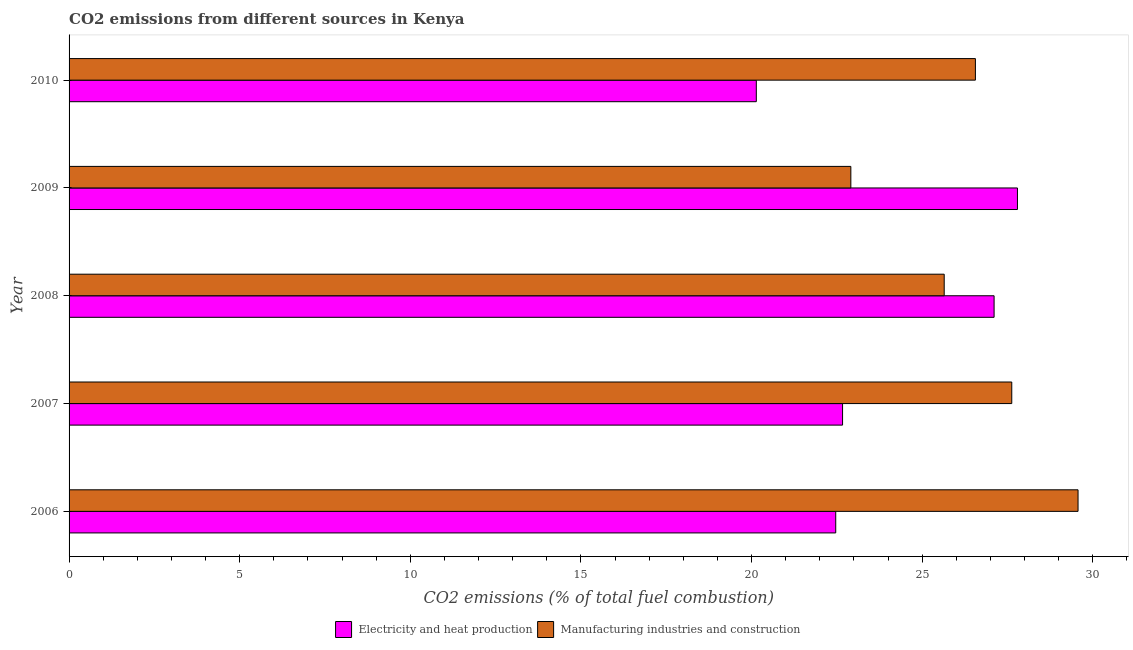How many different coloured bars are there?
Give a very brief answer. 2. Are the number of bars on each tick of the Y-axis equal?
Keep it short and to the point. Yes. How many bars are there on the 5th tick from the bottom?
Ensure brevity in your answer.  2. What is the co2 emissions due to manufacturing industries in 2008?
Give a very brief answer. 25.65. Across all years, what is the maximum co2 emissions due to manufacturing industries?
Your answer should be very brief. 29.57. Across all years, what is the minimum co2 emissions due to electricity and heat production?
Give a very brief answer. 20.14. What is the total co2 emissions due to manufacturing industries in the graph?
Your response must be concise. 132.31. What is the difference between the co2 emissions due to electricity and heat production in 2009 and the co2 emissions due to manufacturing industries in 2008?
Ensure brevity in your answer.  2.15. What is the average co2 emissions due to electricity and heat production per year?
Provide a short and direct response. 24.04. In the year 2007, what is the difference between the co2 emissions due to electricity and heat production and co2 emissions due to manufacturing industries?
Give a very brief answer. -4.96. What is the ratio of the co2 emissions due to manufacturing industries in 2009 to that in 2010?
Offer a very short reply. 0.86. Is the difference between the co2 emissions due to manufacturing industries in 2007 and 2008 greater than the difference between the co2 emissions due to electricity and heat production in 2007 and 2008?
Offer a very short reply. Yes. What is the difference between the highest and the second highest co2 emissions due to electricity and heat production?
Keep it short and to the point. 0.68. What is the difference between the highest and the lowest co2 emissions due to manufacturing industries?
Provide a succinct answer. 6.66. In how many years, is the co2 emissions due to electricity and heat production greater than the average co2 emissions due to electricity and heat production taken over all years?
Give a very brief answer. 2. Is the sum of the co2 emissions due to electricity and heat production in 2006 and 2007 greater than the maximum co2 emissions due to manufacturing industries across all years?
Your response must be concise. Yes. What does the 1st bar from the top in 2006 represents?
Offer a terse response. Manufacturing industries and construction. What does the 1st bar from the bottom in 2009 represents?
Give a very brief answer. Electricity and heat production. Are the values on the major ticks of X-axis written in scientific E-notation?
Your response must be concise. No. Does the graph contain any zero values?
Give a very brief answer. No. How many legend labels are there?
Give a very brief answer. 2. What is the title of the graph?
Keep it short and to the point. CO2 emissions from different sources in Kenya. Does "Subsidies" appear as one of the legend labels in the graph?
Your answer should be very brief. No. What is the label or title of the X-axis?
Your response must be concise. CO2 emissions (% of total fuel combustion). What is the label or title of the Y-axis?
Your response must be concise. Year. What is the CO2 emissions (% of total fuel combustion) of Electricity and heat production in 2006?
Provide a short and direct response. 22.47. What is the CO2 emissions (% of total fuel combustion) of Manufacturing industries and construction in 2006?
Your answer should be very brief. 29.57. What is the CO2 emissions (% of total fuel combustion) of Electricity and heat production in 2007?
Provide a succinct answer. 22.67. What is the CO2 emissions (% of total fuel combustion) of Manufacturing industries and construction in 2007?
Provide a short and direct response. 27.63. What is the CO2 emissions (% of total fuel combustion) of Electricity and heat production in 2008?
Keep it short and to the point. 27.11. What is the CO2 emissions (% of total fuel combustion) in Manufacturing industries and construction in 2008?
Give a very brief answer. 25.65. What is the CO2 emissions (% of total fuel combustion) in Electricity and heat production in 2009?
Make the answer very short. 27.79. What is the CO2 emissions (% of total fuel combustion) in Manufacturing industries and construction in 2009?
Provide a short and direct response. 22.91. What is the CO2 emissions (% of total fuel combustion) in Electricity and heat production in 2010?
Provide a succinct answer. 20.14. What is the CO2 emissions (% of total fuel combustion) of Manufacturing industries and construction in 2010?
Make the answer very short. 26.56. Across all years, what is the maximum CO2 emissions (% of total fuel combustion) in Electricity and heat production?
Make the answer very short. 27.79. Across all years, what is the maximum CO2 emissions (% of total fuel combustion) in Manufacturing industries and construction?
Your answer should be very brief. 29.57. Across all years, what is the minimum CO2 emissions (% of total fuel combustion) in Electricity and heat production?
Offer a terse response. 20.14. Across all years, what is the minimum CO2 emissions (% of total fuel combustion) of Manufacturing industries and construction?
Offer a terse response. 22.91. What is the total CO2 emissions (% of total fuel combustion) in Electricity and heat production in the graph?
Offer a very short reply. 120.18. What is the total CO2 emissions (% of total fuel combustion) of Manufacturing industries and construction in the graph?
Keep it short and to the point. 132.31. What is the difference between the CO2 emissions (% of total fuel combustion) of Electricity and heat production in 2006 and that in 2007?
Ensure brevity in your answer.  -0.2. What is the difference between the CO2 emissions (% of total fuel combustion) of Manufacturing industries and construction in 2006 and that in 2007?
Offer a terse response. 1.94. What is the difference between the CO2 emissions (% of total fuel combustion) in Electricity and heat production in 2006 and that in 2008?
Make the answer very short. -4.64. What is the difference between the CO2 emissions (% of total fuel combustion) of Manufacturing industries and construction in 2006 and that in 2008?
Give a very brief answer. 3.92. What is the difference between the CO2 emissions (% of total fuel combustion) of Electricity and heat production in 2006 and that in 2009?
Offer a terse response. -5.33. What is the difference between the CO2 emissions (% of total fuel combustion) in Manufacturing industries and construction in 2006 and that in 2009?
Give a very brief answer. 6.66. What is the difference between the CO2 emissions (% of total fuel combustion) in Electricity and heat production in 2006 and that in 2010?
Make the answer very short. 2.33. What is the difference between the CO2 emissions (% of total fuel combustion) in Manufacturing industries and construction in 2006 and that in 2010?
Your answer should be very brief. 3.01. What is the difference between the CO2 emissions (% of total fuel combustion) in Electricity and heat production in 2007 and that in 2008?
Provide a succinct answer. -4.44. What is the difference between the CO2 emissions (% of total fuel combustion) of Manufacturing industries and construction in 2007 and that in 2008?
Ensure brevity in your answer.  1.98. What is the difference between the CO2 emissions (% of total fuel combustion) in Electricity and heat production in 2007 and that in 2009?
Offer a very short reply. -5.13. What is the difference between the CO2 emissions (% of total fuel combustion) of Manufacturing industries and construction in 2007 and that in 2009?
Offer a terse response. 4.72. What is the difference between the CO2 emissions (% of total fuel combustion) in Electricity and heat production in 2007 and that in 2010?
Provide a succinct answer. 2.53. What is the difference between the CO2 emissions (% of total fuel combustion) of Manufacturing industries and construction in 2007 and that in 2010?
Your answer should be compact. 1.07. What is the difference between the CO2 emissions (% of total fuel combustion) in Electricity and heat production in 2008 and that in 2009?
Offer a very short reply. -0.68. What is the difference between the CO2 emissions (% of total fuel combustion) in Manufacturing industries and construction in 2008 and that in 2009?
Keep it short and to the point. 2.74. What is the difference between the CO2 emissions (% of total fuel combustion) in Electricity and heat production in 2008 and that in 2010?
Your response must be concise. 6.97. What is the difference between the CO2 emissions (% of total fuel combustion) in Manufacturing industries and construction in 2008 and that in 2010?
Your response must be concise. -0.91. What is the difference between the CO2 emissions (% of total fuel combustion) in Electricity and heat production in 2009 and that in 2010?
Offer a very short reply. 7.65. What is the difference between the CO2 emissions (% of total fuel combustion) of Manufacturing industries and construction in 2009 and that in 2010?
Ensure brevity in your answer.  -3.65. What is the difference between the CO2 emissions (% of total fuel combustion) in Electricity and heat production in 2006 and the CO2 emissions (% of total fuel combustion) in Manufacturing industries and construction in 2007?
Ensure brevity in your answer.  -5.16. What is the difference between the CO2 emissions (% of total fuel combustion) in Electricity and heat production in 2006 and the CO2 emissions (% of total fuel combustion) in Manufacturing industries and construction in 2008?
Your answer should be compact. -3.18. What is the difference between the CO2 emissions (% of total fuel combustion) of Electricity and heat production in 2006 and the CO2 emissions (% of total fuel combustion) of Manufacturing industries and construction in 2009?
Offer a very short reply. -0.44. What is the difference between the CO2 emissions (% of total fuel combustion) in Electricity and heat production in 2006 and the CO2 emissions (% of total fuel combustion) in Manufacturing industries and construction in 2010?
Make the answer very short. -4.09. What is the difference between the CO2 emissions (% of total fuel combustion) of Electricity and heat production in 2007 and the CO2 emissions (% of total fuel combustion) of Manufacturing industries and construction in 2008?
Your response must be concise. -2.98. What is the difference between the CO2 emissions (% of total fuel combustion) in Electricity and heat production in 2007 and the CO2 emissions (% of total fuel combustion) in Manufacturing industries and construction in 2009?
Offer a terse response. -0.24. What is the difference between the CO2 emissions (% of total fuel combustion) in Electricity and heat production in 2007 and the CO2 emissions (% of total fuel combustion) in Manufacturing industries and construction in 2010?
Offer a terse response. -3.89. What is the difference between the CO2 emissions (% of total fuel combustion) of Electricity and heat production in 2008 and the CO2 emissions (% of total fuel combustion) of Manufacturing industries and construction in 2009?
Ensure brevity in your answer.  4.2. What is the difference between the CO2 emissions (% of total fuel combustion) in Electricity and heat production in 2008 and the CO2 emissions (% of total fuel combustion) in Manufacturing industries and construction in 2010?
Provide a succinct answer. 0.55. What is the difference between the CO2 emissions (% of total fuel combustion) of Electricity and heat production in 2009 and the CO2 emissions (% of total fuel combustion) of Manufacturing industries and construction in 2010?
Offer a very short reply. 1.23. What is the average CO2 emissions (% of total fuel combustion) of Electricity and heat production per year?
Provide a succinct answer. 24.04. What is the average CO2 emissions (% of total fuel combustion) in Manufacturing industries and construction per year?
Your answer should be very brief. 26.46. In the year 2006, what is the difference between the CO2 emissions (% of total fuel combustion) in Electricity and heat production and CO2 emissions (% of total fuel combustion) in Manufacturing industries and construction?
Your response must be concise. -7.1. In the year 2007, what is the difference between the CO2 emissions (% of total fuel combustion) in Electricity and heat production and CO2 emissions (% of total fuel combustion) in Manufacturing industries and construction?
Offer a very short reply. -4.96. In the year 2008, what is the difference between the CO2 emissions (% of total fuel combustion) in Electricity and heat production and CO2 emissions (% of total fuel combustion) in Manufacturing industries and construction?
Offer a terse response. 1.46. In the year 2009, what is the difference between the CO2 emissions (% of total fuel combustion) of Electricity and heat production and CO2 emissions (% of total fuel combustion) of Manufacturing industries and construction?
Offer a terse response. 4.88. In the year 2010, what is the difference between the CO2 emissions (% of total fuel combustion) in Electricity and heat production and CO2 emissions (% of total fuel combustion) in Manufacturing industries and construction?
Provide a succinct answer. -6.42. What is the ratio of the CO2 emissions (% of total fuel combustion) of Electricity and heat production in 2006 to that in 2007?
Your answer should be compact. 0.99. What is the ratio of the CO2 emissions (% of total fuel combustion) of Manufacturing industries and construction in 2006 to that in 2007?
Provide a short and direct response. 1.07. What is the ratio of the CO2 emissions (% of total fuel combustion) in Electricity and heat production in 2006 to that in 2008?
Make the answer very short. 0.83. What is the ratio of the CO2 emissions (% of total fuel combustion) of Manufacturing industries and construction in 2006 to that in 2008?
Ensure brevity in your answer.  1.15. What is the ratio of the CO2 emissions (% of total fuel combustion) of Electricity and heat production in 2006 to that in 2009?
Make the answer very short. 0.81. What is the ratio of the CO2 emissions (% of total fuel combustion) in Manufacturing industries and construction in 2006 to that in 2009?
Offer a terse response. 1.29. What is the ratio of the CO2 emissions (% of total fuel combustion) in Electricity and heat production in 2006 to that in 2010?
Your response must be concise. 1.12. What is the ratio of the CO2 emissions (% of total fuel combustion) of Manufacturing industries and construction in 2006 to that in 2010?
Ensure brevity in your answer.  1.11. What is the ratio of the CO2 emissions (% of total fuel combustion) in Electricity and heat production in 2007 to that in 2008?
Ensure brevity in your answer.  0.84. What is the ratio of the CO2 emissions (% of total fuel combustion) in Manufacturing industries and construction in 2007 to that in 2008?
Ensure brevity in your answer.  1.08. What is the ratio of the CO2 emissions (% of total fuel combustion) of Electricity and heat production in 2007 to that in 2009?
Your answer should be very brief. 0.82. What is the ratio of the CO2 emissions (% of total fuel combustion) in Manufacturing industries and construction in 2007 to that in 2009?
Make the answer very short. 1.21. What is the ratio of the CO2 emissions (% of total fuel combustion) in Electricity and heat production in 2007 to that in 2010?
Offer a terse response. 1.13. What is the ratio of the CO2 emissions (% of total fuel combustion) in Manufacturing industries and construction in 2007 to that in 2010?
Provide a short and direct response. 1.04. What is the ratio of the CO2 emissions (% of total fuel combustion) of Electricity and heat production in 2008 to that in 2009?
Offer a very short reply. 0.98. What is the ratio of the CO2 emissions (% of total fuel combustion) in Manufacturing industries and construction in 2008 to that in 2009?
Your answer should be very brief. 1.12. What is the ratio of the CO2 emissions (% of total fuel combustion) in Electricity and heat production in 2008 to that in 2010?
Make the answer very short. 1.35. What is the ratio of the CO2 emissions (% of total fuel combustion) of Manufacturing industries and construction in 2008 to that in 2010?
Ensure brevity in your answer.  0.97. What is the ratio of the CO2 emissions (% of total fuel combustion) in Electricity and heat production in 2009 to that in 2010?
Offer a terse response. 1.38. What is the ratio of the CO2 emissions (% of total fuel combustion) of Manufacturing industries and construction in 2009 to that in 2010?
Make the answer very short. 0.86. What is the difference between the highest and the second highest CO2 emissions (% of total fuel combustion) of Electricity and heat production?
Provide a short and direct response. 0.68. What is the difference between the highest and the second highest CO2 emissions (% of total fuel combustion) of Manufacturing industries and construction?
Keep it short and to the point. 1.94. What is the difference between the highest and the lowest CO2 emissions (% of total fuel combustion) in Electricity and heat production?
Provide a succinct answer. 7.65. What is the difference between the highest and the lowest CO2 emissions (% of total fuel combustion) in Manufacturing industries and construction?
Provide a short and direct response. 6.66. 